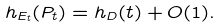<formula> <loc_0><loc_0><loc_500><loc_500>\ h _ { E _ { t } } ( P _ { t } ) = h _ { D } ( t ) + O ( 1 ) .</formula> 